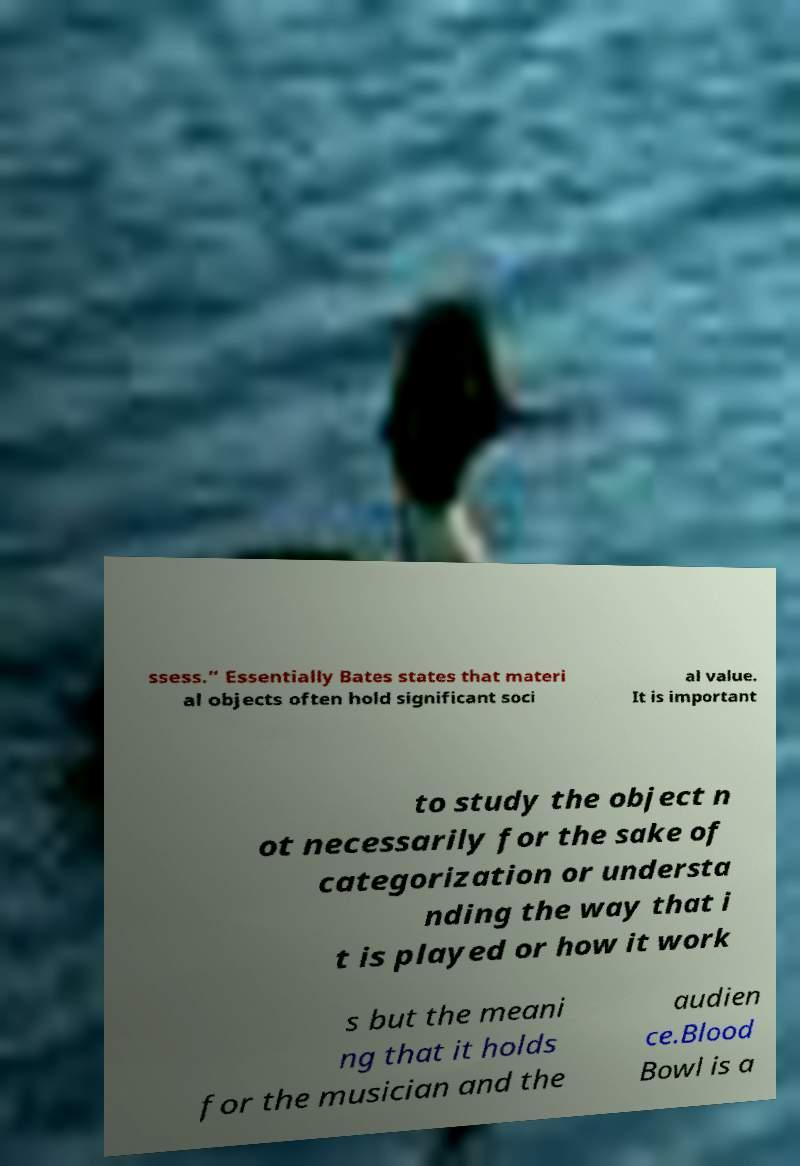Could you assist in decoding the text presented in this image and type it out clearly? ssess.” Essentially Bates states that materi al objects often hold significant soci al value. It is important to study the object n ot necessarily for the sake of categorization or understa nding the way that i t is played or how it work s but the meani ng that it holds for the musician and the audien ce.Blood Bowl is a 